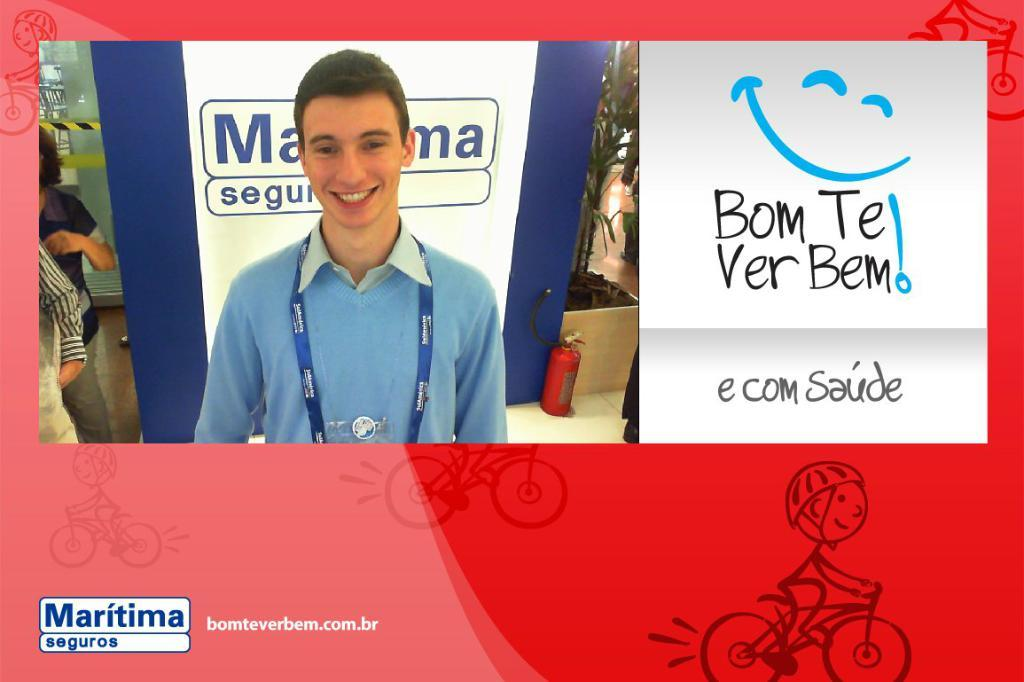<image>
Render a clear and concise summary of the photo. A smiling guy in a blue shirt next to a Bom Te Verbem! sign 